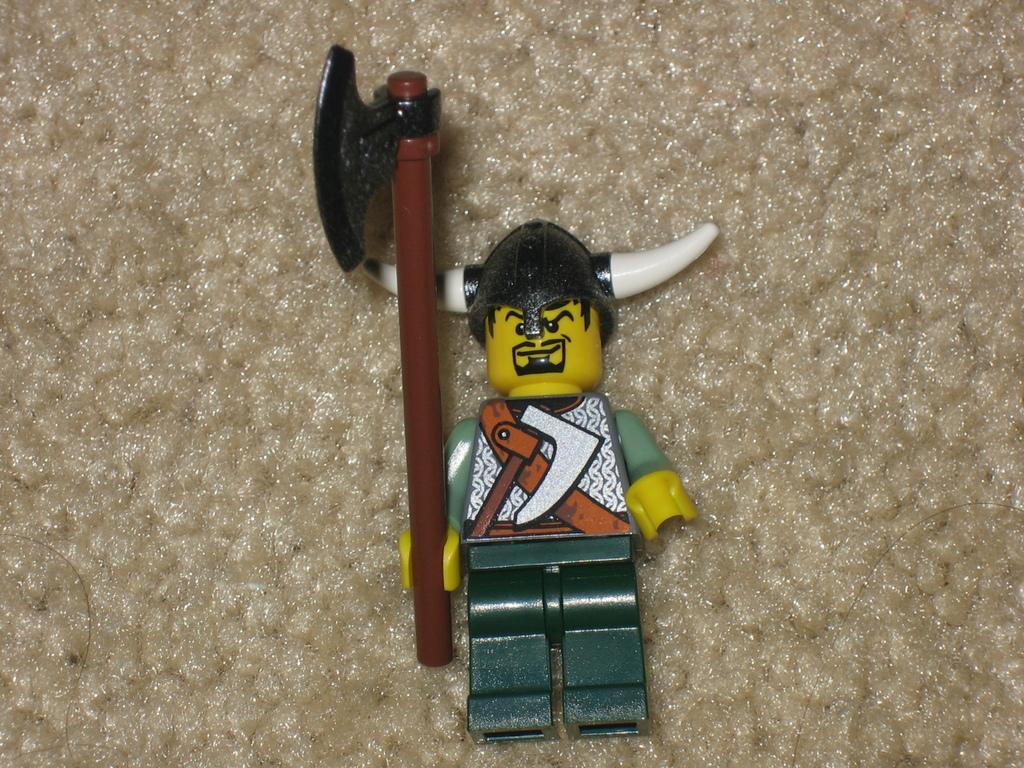Please provide a concise description of this image. In the center of the image there is a toy. 